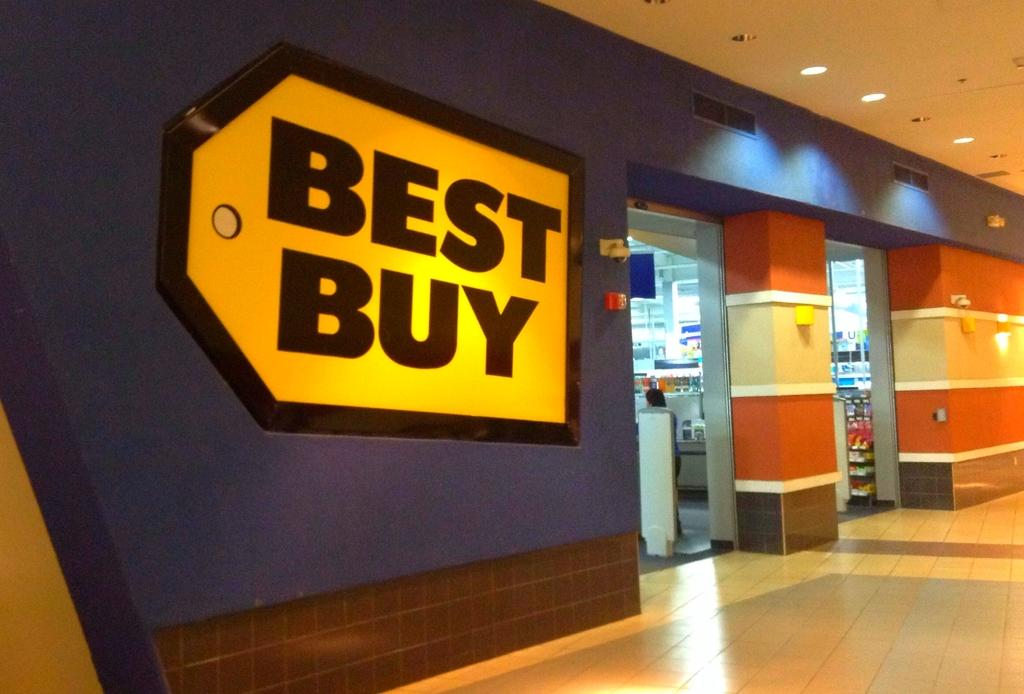<image>
Create a compact narrative representing the image presented. Entrance to the BEST Buy store with lights shining at the opening. 